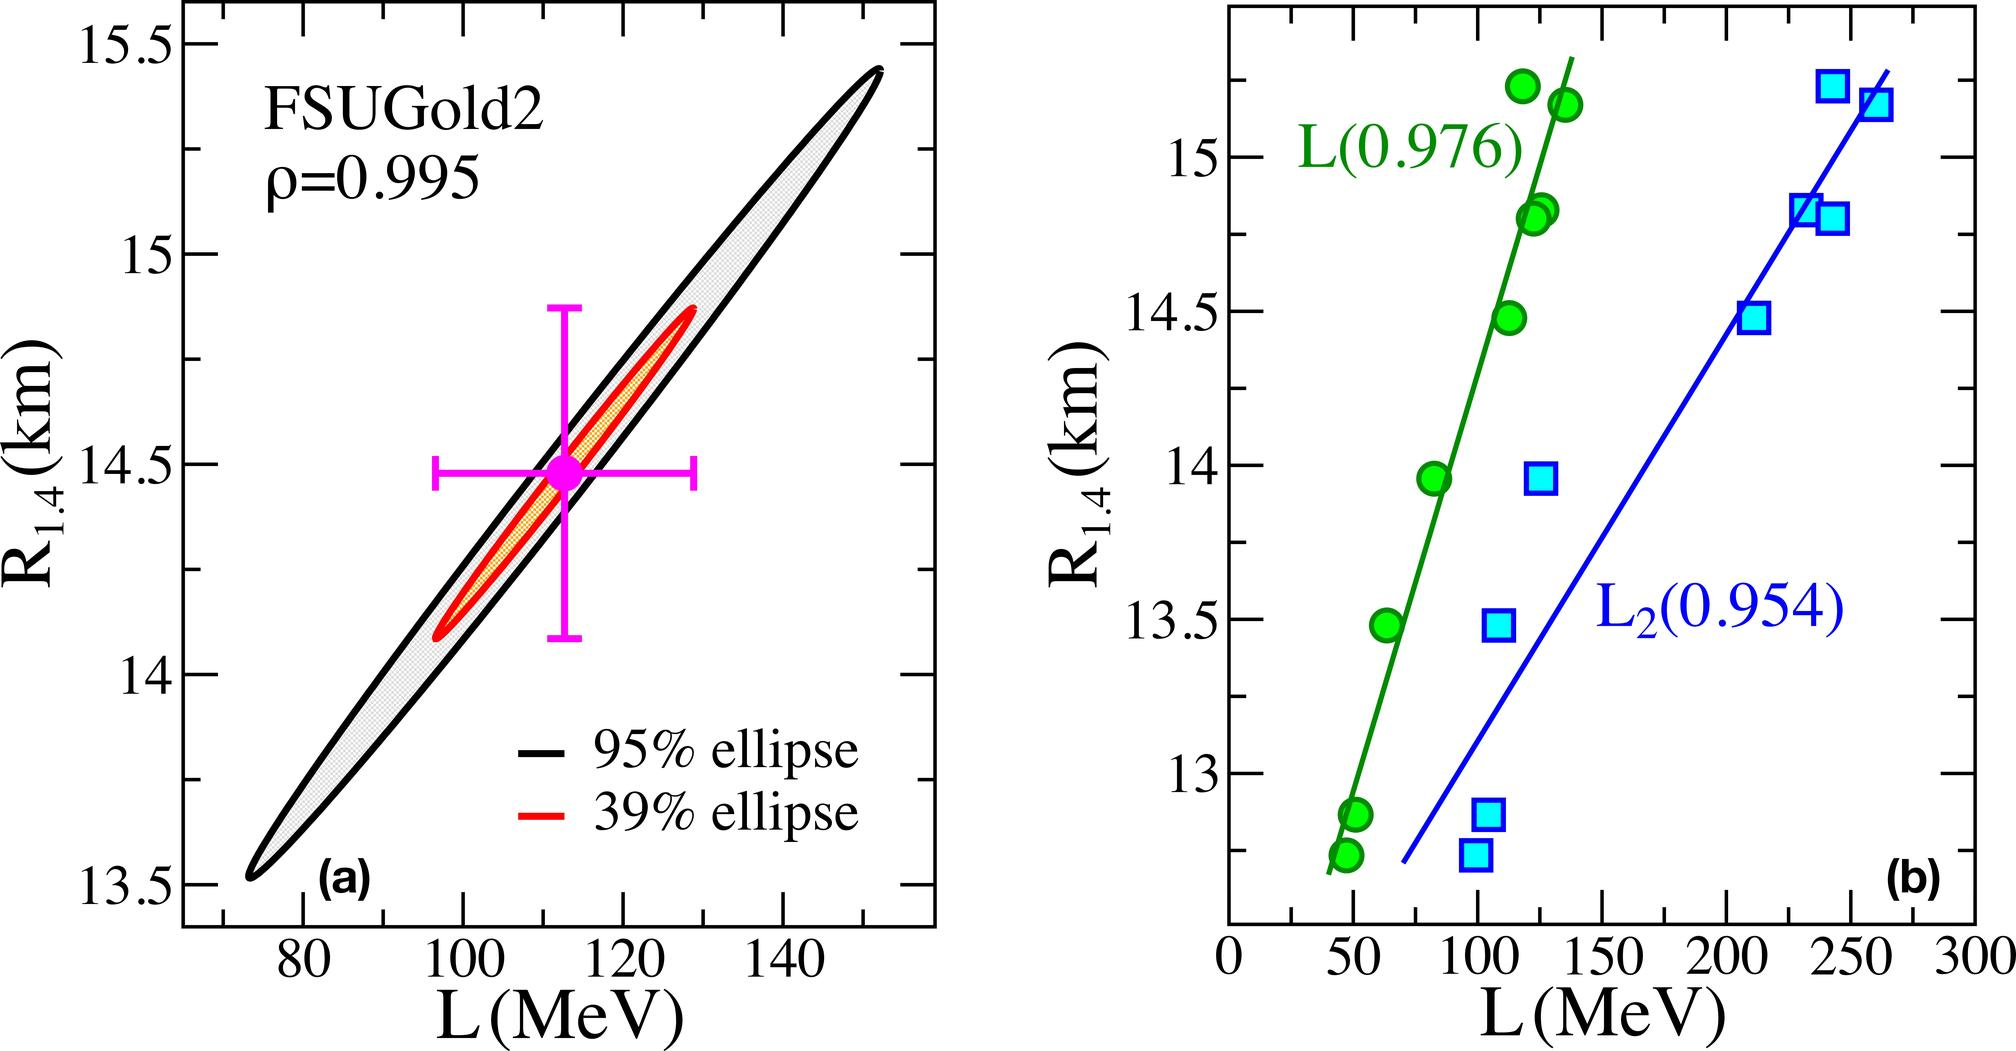What is the correlation coefficient (ρ) for the FSUGold2 equation of state (EoS) as shown in the figure (a)? A. ρ=0.995 B. ρ=0.976 C. ρ=0.954 D. ρ=0.850 The correlation coefficient for the FSUGold2 EoS is explicitly stated as ρ=0.995 in the figure (a). Therefore, the correct answer is A. 